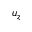Convert formula to latex. <formula><loc_0><loc_0><loc_500><loc_500>u _ { z }</formula> 